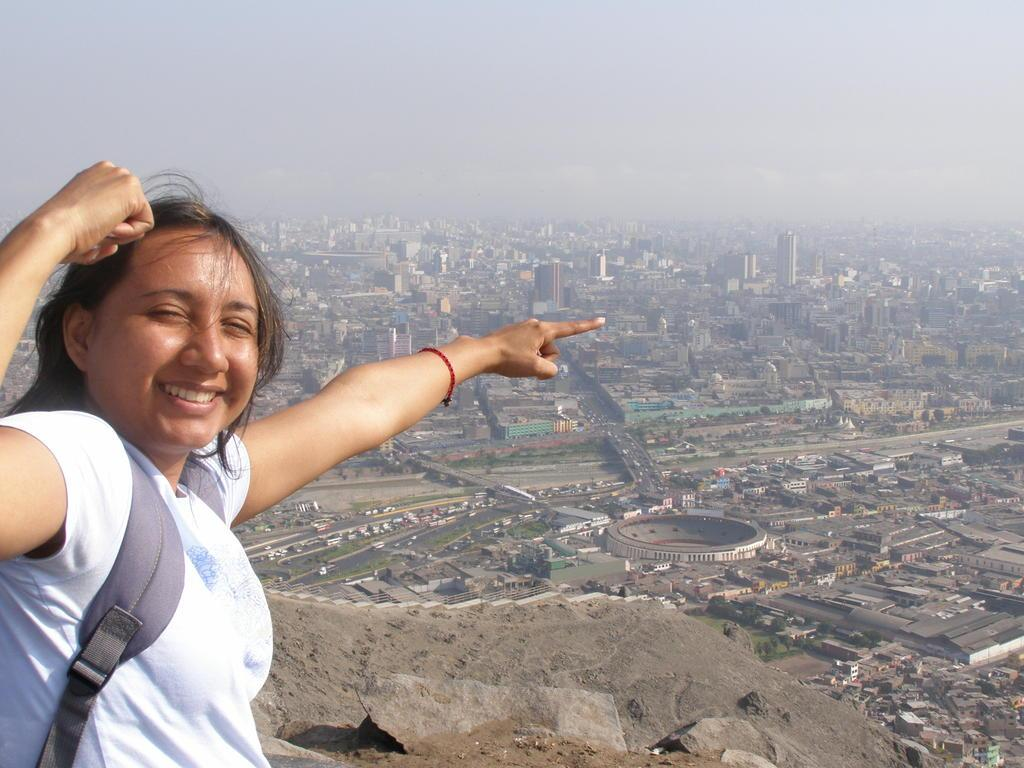Who is on the left side of the image? There is a woman on the left side of the image. What can be seen in the background of the image? Buildings, trees, a stadium, roads, vehicles, the sky, and clouds are present in the background of the image. What type of wax can be seen melting on the island in the image? There is no wax or island present in the image. 